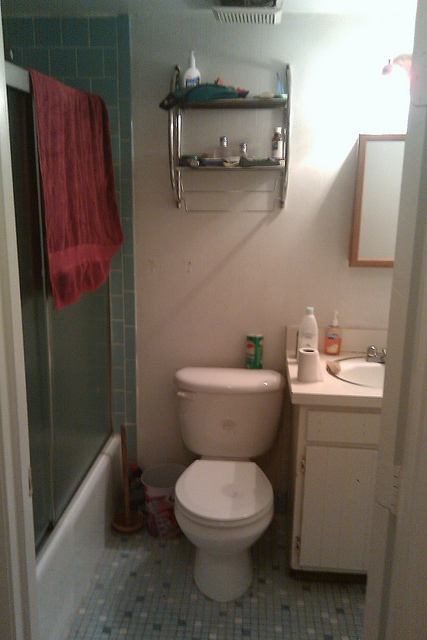What type of flooring is used in the bathroom? The bathroom floor is covered with small, square, light blue tiles that provide a classic and functional flooring solution for the wet environment of the bathroom.  Describe the storage situation in the bathroom. The storage in the bathroom is quite minimal, consisting of a metal rack above the toilet tank with a few items stored on it, and an under-sink cabinet that may provide additional storage space out of view. 